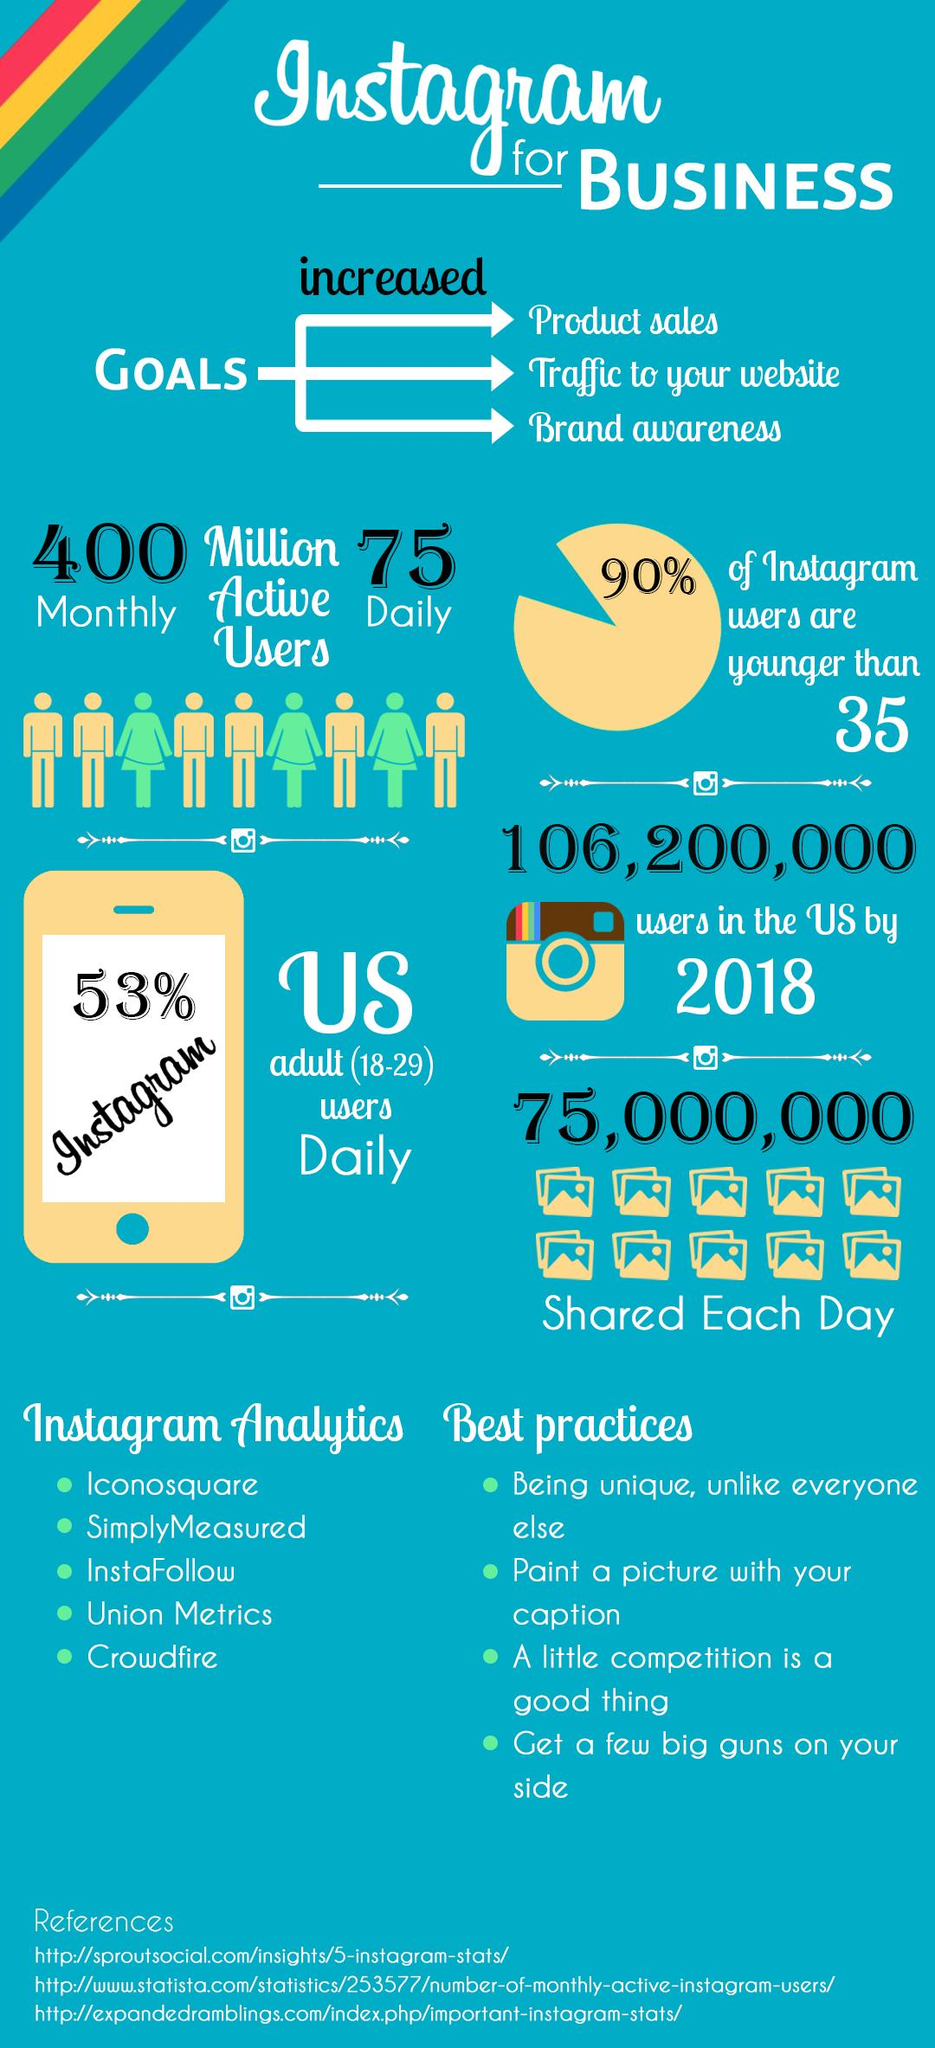Identify some key points in this picture. Approximately 10% of Instagram users are older than 35. 